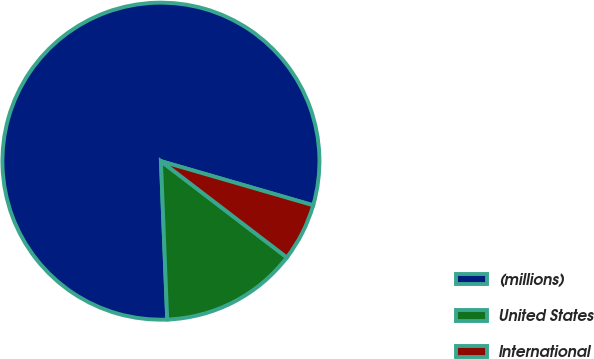Convert chart to OTSL. <chart><loc_0><loc_0><loc_500><loc_500><pie_chart><fcel>(millions)<fcel>United States<fcel>International<nl><fcel>80.12%<fcel>13.98%<fcel>5.9%<nl></chart> 